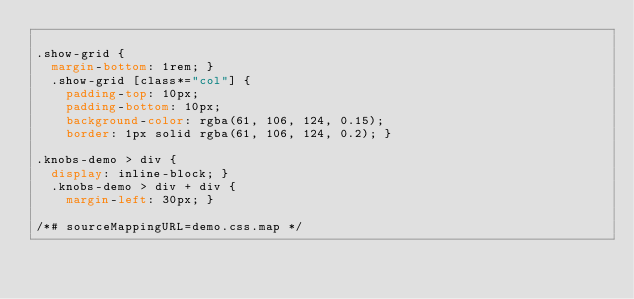Convert code to text. <code><loc_0><loc_0><loc_500><loc_500><_CSS_>
.show-grid {
  margin-bottom: 1rem; }
  .show-grid [class*="col"] {
    padding-top: 10px;
    padding-bottom: 10px;
    background-color: rgba(61, 106, 124, 0.15);
    border: 1px solid rgba(61, 106, 124, 0.2); }

.knobs-demo > div {
  display: inline-block; }
  .knobs-demo > div + div {
    margin-left: 30px; }

/*# sourceMappingURL=demo.css.map */
</code> 